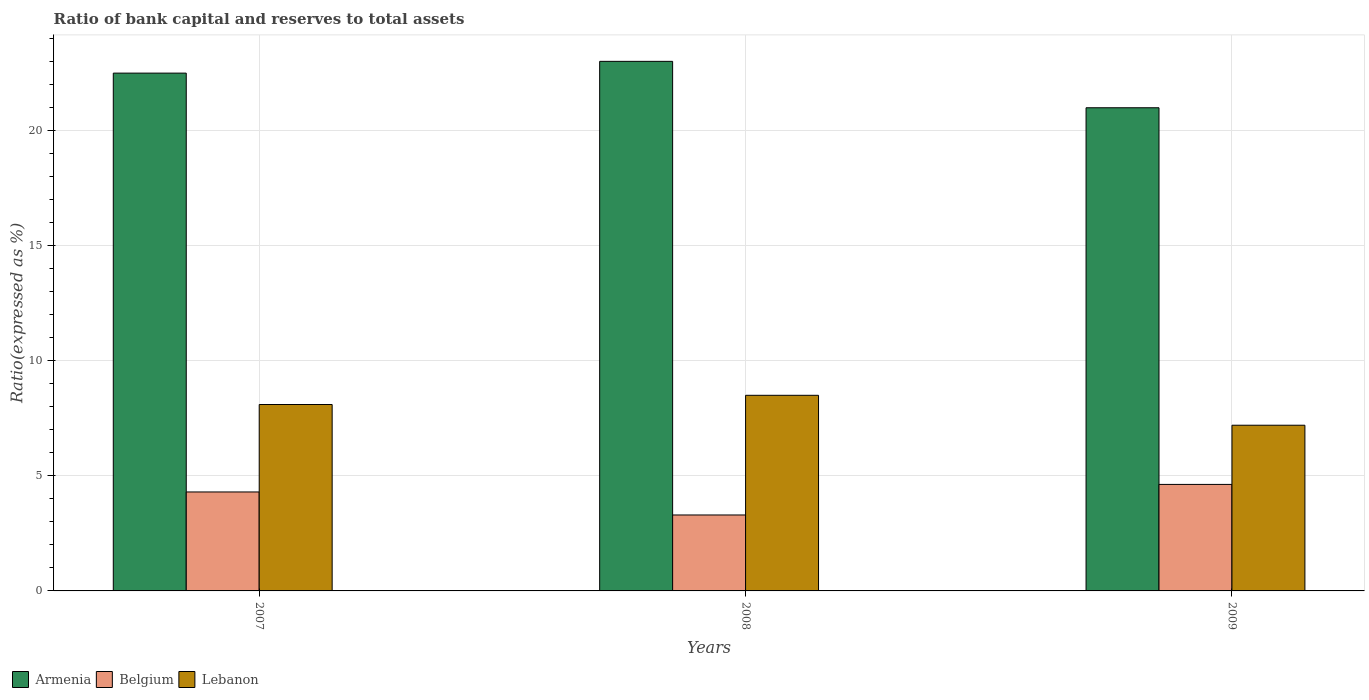How many groups of bars are there?
Provide a short and direct response. 3. Are the number of bars on each tick of the X-axis equal?
Your answer should be compact. Yes. How many bars are there on the 2nd tick from the right?
Your answer should be compact. 3. In how many cases, is the number of bars for a given year not equal to the number of legend labels?
Offer a terse response. 0. What is the ratio of bank capital and reserves to total assets in Belgium in 2008?
Keep it short and to the point. 3.3. Across all years, what is the maximum ratio of bank capital and reserves to total assets in Armenia?
Your answer should be compact. 23.01. What is the total ratio of bank capital and reserves to total assets in Lebanon in the graph?
Your answer should be compact. 23.8. What is the difference between the ratio of bank capital and reserves to total assets in Lebanon in 2007 and that in 2008?
Offer a very short reply. -0.4. What is the difference between the ratio of bank capital and reserves to total assets in Armenia in 2008 and the ratio of bank capital and reserves to total assets in Belgium in 2009?
Keep it short and to the point. 18.38. What is the average ratio of bank capital and reserves to total assets in Lebanon per year?
Ensure brevity in your answer.  7.93. In the year 2007, what is the difference between the ratio of bank capital and reserves to total assets in Belgium and ratio of bank capital and reserves to total assets in Armenia?
Provide a succinct answer. -18.2. In how many years, is the ratio of bank capital and reserves to total assets in Lebanon greater than 18 %?
Your answer should be compact. 0. What is the ratio of the ratio of bank capital and reserves to total assets in Armenia in 2007 to that in 2009?
Provide a short and direct response. 1.07. Is the ratio of bank capital and reserves to total assets in Armenia in 2008 less than that in 2009?
Keep it short and to the point. No. What is the difference between the highest and the second highest ratio of bank capital and reserves to total assets in Armenia?
Offer a terse response. 0.51. What is the difference between the highest and the lowest ratio of bank capital and reserves to total assets in Armenia?
Keep it short and to the point. 2.02. In how many years, is the ratio of bank capital and reserves to total assets in Lebanon greater than the average ratio of bank capital and reserves to total assets in Lebanon taken over all years?
Provide a short and direct response. 2. Is the sum of the ratio of bank capital and reserves to total assets in Belgium in 2008 and 2009 greater than the maximum ratio of bank capital and reserves to total assets in Lebanon across all years?
Your answer should be compact. No. Is it the case that in every year, the sum of the ratio of bank capital and reserves to total assets in Lebanon and ratio of bank capital and reserves to total assets in Belgium is greater than the ratio of bank capital and reserves to total assets in Armenia?
Your answer should be very brief. No. Are all the bars in the graph horizontal?
Offer a very short reply. No. Does the graph contain grids?
Your answer should be compact. Yes. Where does the legend appear in the graph?
Your answer should be compact. Bottom left. How are the legend labels stacked?
Your answer should be very brief. Horizontal. What is the title of the graph?
Make the answer very short. Ratio of bank capital and reserves to total assets. What is the label or title of the Y-axis?
Offer a very short reply. Ratio(expressed as %). What is the Ratio(expressed as %) of Armenia in 2008?
Your answer should be very brief. 23.01. What is the Ratio(expressed as %) in Lebanon in 2008?
Keep it short and to the point. 8.5. What is the Ratio(expressed as %) in Armenia in 2009?
Your answer should be very brief. 20.99. What is the Ratio(expressed as %) in Belgium in 2009?
Offer a terse response. 4.63. What is the Ratio(expressed as %) of Lebanon in 2009?
Provide a succinct answer. 7.2. Across all years, what is the maximum Ratio(expressed as %) in Armenia?
Give a very brief answer. 23.01. Across all years, what is the maximum Ratio(expressed as %) in Belgium?
Your response must be concise. 4.63. Across all years, what is the maximum Ratio(expressed as %) in Lebanon?
Ensure brevity in your answer.  8.5. Across all years, what is the minimum Ratio(expressed as %) of Armenia?
Your response must be concise. 20.99. Across all years, what is the minimum Ratio(expressed as %) in Belgium?
Provide a succinct answer. 3.3. What is the total Ratio(expressed as %) of Armenia in the graph?
Your answer should be very brief. 66.51. What is the total Ratio(expressed as %) in Belgium in the graph?
Your answer should be very brief. 12.23. What is the total Ratio(expressed as %) of Lebanon in the graph?
Your response must be concise. 23.8. What is the difference between the Ratio(expressed as %) of Armenia in 2007 and that in 2008?
Make the answer very short. -0.51. What is the difference between the Ratio(expressed as %) in Belgium in 2007 and that in 2008?
Make the answer very short. 1. What is the difference between the Ratio(expressed as %) in Armenia in 2007 and that in 2009?
Offer a very short reply. 1.51. What is the difference between the Ratio(expressed as %) of Belgium in 2007 and that in 2009?
Ensure brevity in your answer.  -0.33. What is the difference between the Ratio(expressed as %) in Armenia in 2008 and that in 2009?
Offer a very short reply. 2.02. What is the difference between the Ratio(expressed as %) of Belgium in 2008 and that in 2009?
Keep it short and to the point. -1.33. What is the difference between the Ratio(expressed as %) in Armenia in 2007 and the Ratio(expressed as %) in Belgium in 2008?
Your response must be concise. 19.2. What is the difference between the Ratio(expressed as %) in Armenia in 2007 and the Ratio(expressed as %) in Lebanon in 2008?
Offer a very short reply. 14. What is the difference between the Ratio(expressed as %) of Armenia in 2007 and the Ratio(expressed as %) of Belgium in 2009?
Your response must be concise. 17.87. What is the difference between the Ratio(expressed as %) in Belgium in 2007 and the Ratio(expressed as %) in Lebanon in 2009?
Offer a terse response. -2.9. What is the difference between the Ratio(expressed as %) of Armenia in 2008 and the Ratio(expressed as %) of Belgium in 2009?
Your answer should be compact. 18.38. What is the difference between the Ratio(expressed as %) of Armenia in 2008 and the Ratio(expressed as %) of Lebanon in 2009?
Offer a very short reply. 15.81. What is the average Ratio(expressed as %) in Armenia per year?
Give a very brief answer. 22.17. What is the average Ratio(expressed as %) of Belgium per year?
Your answer should be very brief. 4.08. What is the average Ratio(expressed as %) of Lebanon per year?
Keep it short and to the point. 7.93. In the year 2007, what is the difference between the Ratio(expressed as %) of Armenia and Ratio(expressed as %) of Belgium?
Offer a terse response. 18.2. In the year 2007, what is the difference between the Ratio(expressed as %) in Armenia and Ratio(expressed as %) in Lebanon?
Your answer should be very brief. 14.4. In the year 2008, what is the difference between the Ratio(expressed as %) of Armenia and Ratio(expressed as %) of Belgium?
Offer a very short reply. 19.71. In the year 2008, what is the difference between the Ratio(expressed as %) of Armenia and Ratio(expressed as %) of Lebanon?
Give a very brief answer. 14.51. In the year 2009, what is the difference between the Ratio(expressed as %) in Armenia and Ratio(expressed as %) in Belgium?
Give a very brief answer. 16.37. In the year 2009, what is the difference between the Ratio(expressed as %) in Armenia and Ratio(expressed as %) in Lebanon?
Give a very brief answer. 13.79. In the year 2009, what is the difference between the Ratio(expressed as %) of Belgium and Ratio(expressed as %) of Lebanon?
Make the answer very short. -2.57. What is the ratio of the Ratio(expressed as %) in Armenia in 2007 to that in 2008?
Your answer should be very brief. 0.98. What is the ratio of the Ratio(expressed as %) in Belgium in 2007 to that in 2008?
Ensure brevity in your answer.  1.3. What is the ratio of the Ratio(expressed as %) in Lebanon in 2007 to that in 2008?
Provide a short and direct response. 0.95. What is the ratio of the Ratio(expressed as %) in Armenia in 2007 to that in 2009?
Offer a very short reply. 1.07. What is the ratio of the Ratio(expressed as %) in Belgium in 2007 to that in 2009?
Offer a terse response. 0.93. What is the ratio of the Ratio(expressed as %) in Lebanon in 2007 to that in 2009?
Ensure brevity in your answer.  1.12. What is the ratio of the Ratio(expressed as %) of Armenia in 2008 to that in 2009?
Provide a succinct answer. 1.1. What is the ratio of the Ratio(expressed as %) in Belgium in 2008 to that in 2009?
Your answer should be compact. 0.71. What is the ratio of the Ratio(expressed as %) of Lebanon in 2008 to that in 2009?
Make the answer very short. 1.18. What is the difference between the highest and the second highest Ratio(expressed as %) in Armenia?
Your answer should be very brief. 0.51. What is the difference between the highest and the second highest Ratio(expressed as %) of Belgium?
Give a very brief answer. 0.33. What is the difference between the highest and the lowest Ratio(expressed as %) in Armenia?
Make the answer very short. 2.02. What is the difference between the highest and the lowest Ratio(expressed as %) in Belgium?
Your response must be concise. 1.33. 